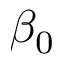Convert formula to latex. <formula><loc_0><loc_0><loc_500><loc_500>\beta _ { 0 }</formula> 